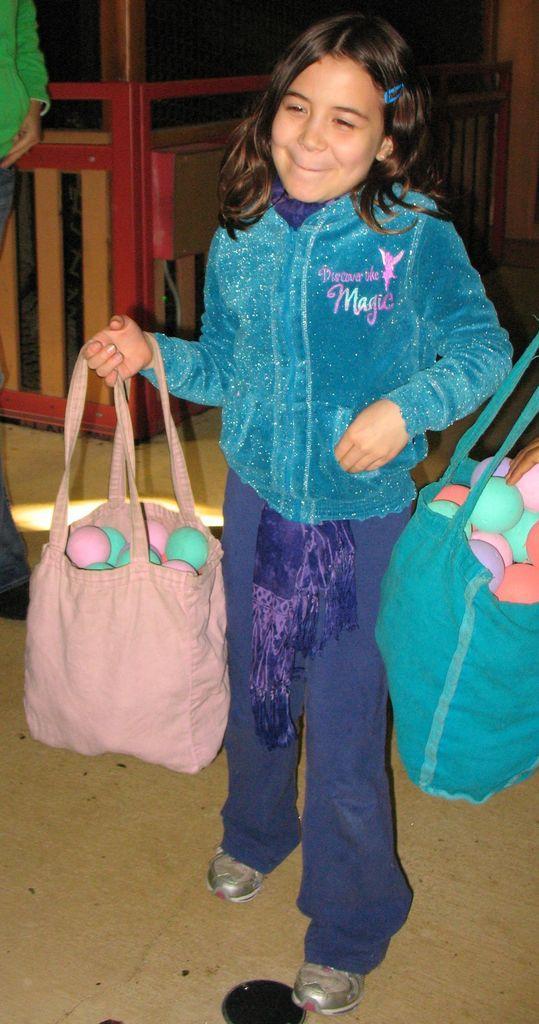How would you summarize this image in a sentence or two? In this picture we can see a girl wore colorful jacket and smiling and carrying bag full of balls in her hand and beside to her we can see balls in bag and in background we can see some person, fence. 